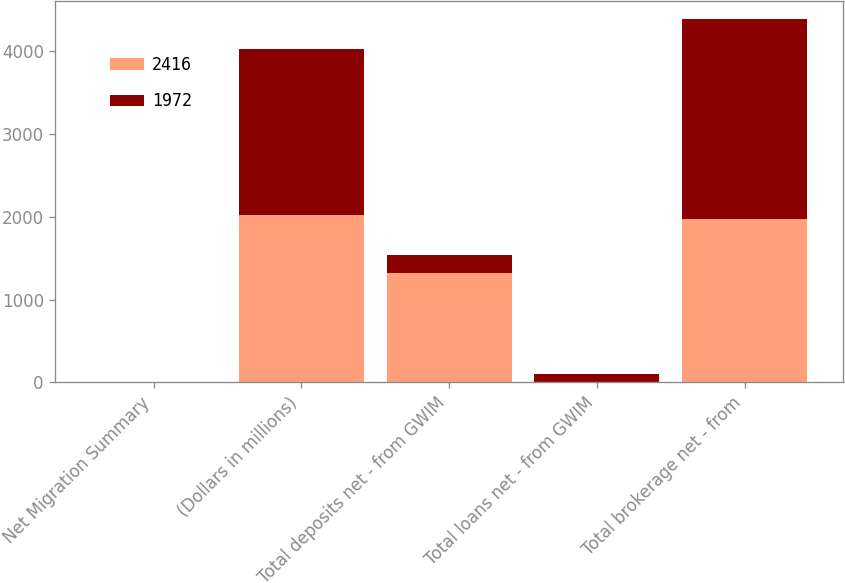Convert chart to OTSL. <chart><loc_0><loc_0><loc_500><loc_500><stacked_bar_chart><ecel><fcel>Net Migration Summary<fcel>(Dollars in millions)<fcel>Total deposits net - from GWIM<fcel>Total loans net - from GWIM<fcel>Total brokerage net - from<nl><fcel>2416<fcel>1<fcel>2016<fcel>1319<fcel>7<fcel>1972<nl><fcel>1972<fcel>1<fcel>2015<fcel>218<fcel>97<fcel>2416<nl></chart> 